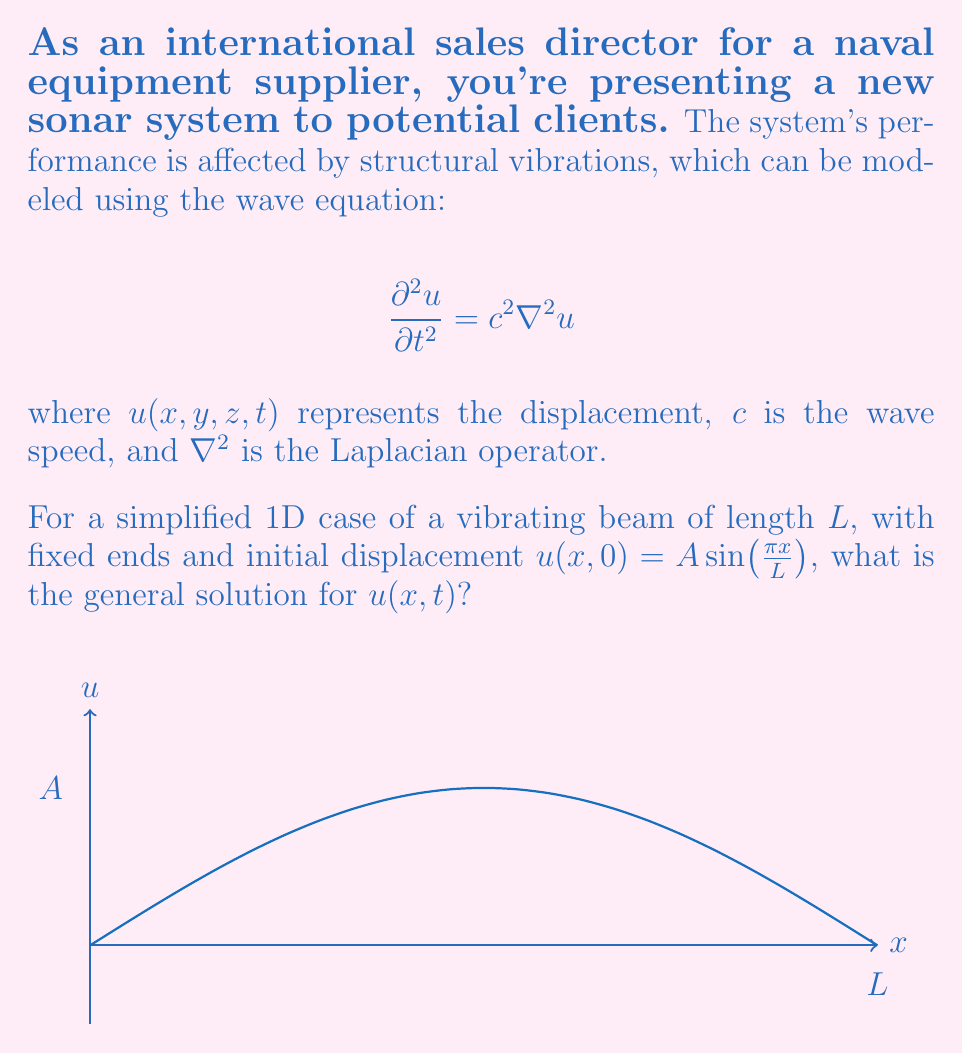Show me your answer to this math problem. To solve this problem, we'll follow these steps:

1) The general solution for the 1D wave equation is of the form:
   $$u(x,t) = [f(x-ct) + g(x+ct)]$$
   where $f$ and $g$ are arbitrary functions.

2) For a beam with fixed ends, we have boundary conditions:
   $$u(0,t) = u(L,t) = 0$$

3) The initial condition is given as:
   $$u(x,0) = A \sin(\frac{\pi x}{L})$$

4) To satisfy the boundary and initial conditions, we can use the method of separation of variables. The solution takes the form:
   $$u(x,t) = X(x)T(t)$$

5) Substituting this into the wave equation and separating variables, we get:
   $$\frac{X''}{X} = \frac{1}{c^2}\frac{T''}{T} = -k^2$$

6) Solving these equations:
   $$X(x) = B \sin(kx)$$
   $$T(t) = C \cos(ckt) + D \sin(ckt)$$

7) To satisfy the boundary conditions, we must have:
   $$k = \frac{n\pi}{L}, \quad n = 1,2,3,...$$

8) The general solution is thus:
   $$u(x,t) = \sum_{n=1}^{\infty} [C_n \cos(\frac{n\pi c}{L}t) + D_n \sin(\frac{n\pi c}{L}t)] \sin(\frac{n\pi x}{L})$$

9) Using the initial condition:
   $$u(x,0) = A \sin(\frac{\pi x}{L}) = \sum_{n=1}^{\infty} C_n \sin(\frac{n\pi x}{L})$$

10) This implies $C_1 = A$ and $C_n = 0$ for $n > 1$.

11) The initial velocity is not specified, so we can assume it's zero:
    $$\frac{\partial u}{\partial t}(x,0) = 0 = \sum_{n=1}^{\infty} D_n \frac{n\pi c}{L} \sin(\frac{n\pi x}{L})$$

12) This implies $D_n = 0$ for all $n$.

Therefore, the final solution is:
$$u(x,t) = A \cos(\frac{\pi c}{L}t) \sin(\frac{\pi x}{L})$$
Answer: $u(x,t) = A \cos(\frac{\pi c}{L}t) \sin(\frac{\pi x}{L})$ 